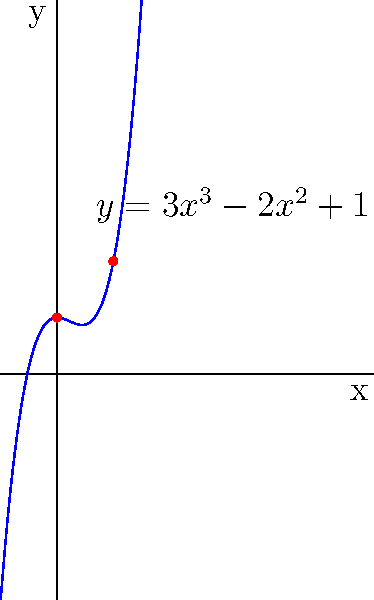In a game environment, you need to create a smooth transition between two lighting states. Given the polynomial function $f(x) = 3x^3 - 2x^2 + 1$ to control the lighting intensity, where $x$ represents time (normalized from 0 to 1) and $f(x)$ represents the lighting intensity, what is the rate of change of lighting intensity at the midpoint of the transition ($x = 0.5$)? To find the rate of change of lighting intensity at $x = 0.5$, we need to follow these steps:

1) The rate of change is represented by the derivative of the function. Let's call this $f'(x)$.

2) To find $f'(x)$, we differentiate $f(x) = 3x^3 - 2x^2 + 1$:
   $f'(x) = 9x^2 - 4x$

3) Now, we need to evaluate $f'(x)$ at $x = 0.5$:
   $f'(0.5) = 9(0.5)^2 - 4(0.5)$

4) Let's calculate this step by step:
   $f'(0.5) = 9(0.25) - 2$
   $f'(0.5) = 2.25 - 2$
   $f'(0.5) = 0.25$

5) Therefore, the rate of change of lighting intensity at the midpoint of the transition ($x = 0.5$) is 0.25.

This positive value indicates that the lighting intensity is increasing at this point, but at a relatively slow rate, which contributes to the smooth transition between the lighting states.
Answer: 0.25 